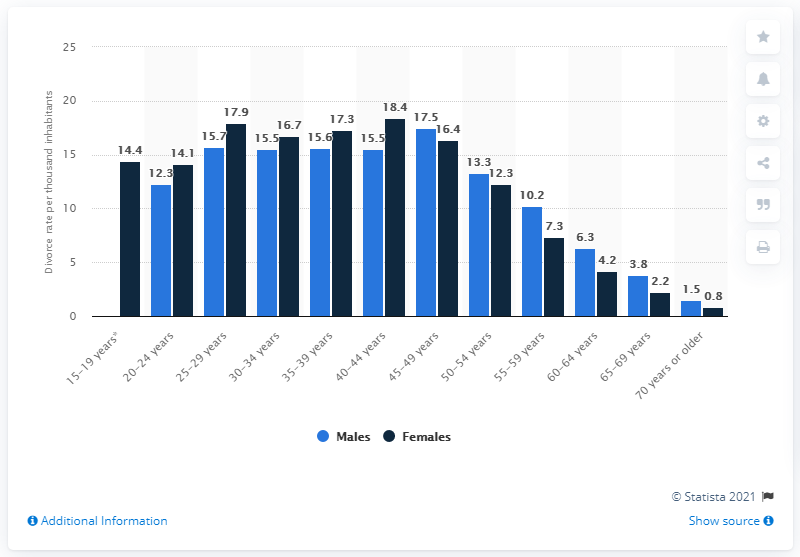Identify some key points in this picture. The age group that had the most divorced males was 45-49 years old. The difference between males and females in the age group of 45-49 years is 1.1. In 2020, there were 18.4 divorces per 1,000 females in Norway. 